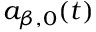Convert formula to latex. <formula><loc_0><loc_0><loc_500><loc_500>a _ { \beta , 0 } ( t )</formula> 